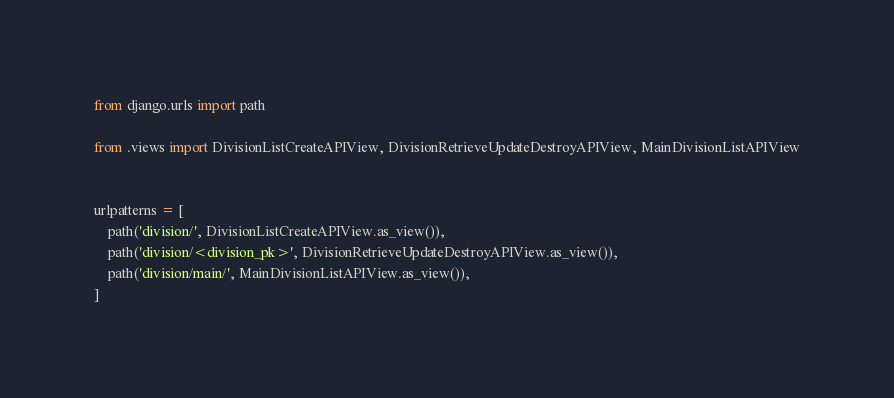<code> <loc_0><loc_0><loc_500><loc_500><_Python_>from django.urls import path

from .views import DivisionListCreateAPIView, DivisionRetrieveUpdateDestroyAPIView, MainDivisionListAPIView


urlpatterns = [
    path('division/', DivisionListCreateAPIView.as_view()),
    path('division/<division_pk>', DivisionRetrieveUpdateDestroyAPIView.as_view()),
    path('division/main/', MainDivisionListAPIView.as_view()),
]
</code> 